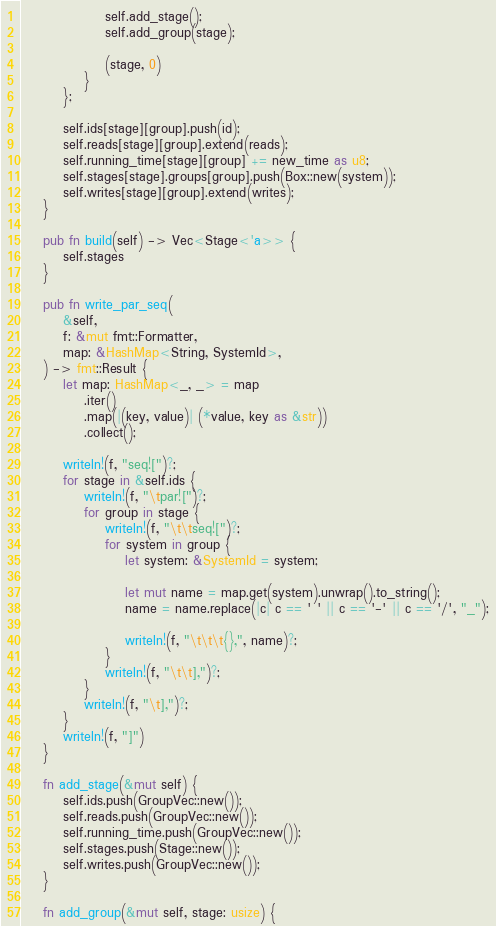<code> <loc_0><loc_0><loc_500><loc_500><_Rust_>                self.add_stage();
                self.add_group(stage);

                (stage, 0)
            }
        };

        self.ids[stage][group].push(id);
        self.reads[stage][group].extend(reads);
        self.running_time[stage][group] += new_time as u8;
        self.stages[stage].groups[group].push(Box::new(system));
        self.writes[stage][group].extend(writes);
    }

    pub fn build(self) -> Vec<Stage<'a>> {
        self.stages
    }

    pub fn write_par_seq(
        &self,
        f: &mut fmt::Formatter,
        map: &HashMap<String, SystemId>,
    ) -> fmt::Result {
        let map: HashMap<_, _> = map
            .iter()
            .map(|(key, value)| (*value, key as &str))
            .collect();

        writeln!(f, "seq![")?;
        for stage in &self.ids {
            writeln!(f, "\tpar![")?;
            for group in stage {
                writeln!(f, "\t\tseq![")?;
                for system in group {
                    let system: &SystemId = system;

                    let mut name = map.get(system).unwrap().to_string();
                    name = name.replace(|c| c == ' ' || c == '-' || c == '/', "_");

                    writeln!(f, "\t\t\t{},", name)?;
                }
                writeln!(f, "\t\t],")?;
            }
            writeln!(f, "\t],")?;
        }
        writeln!(f, "]")
    }

    fn add_stage(&mut self) {
        self.ids.push(GroupVec::new());
        self.reads.push(GroupVec::new());
        self.running_time.push(GroupVec::new());
        self.stages.push(Stage::new());
        self.writes.push(GroupVec::new());
    }

    fn add_group(&mut self, stage: usize) {</code> 